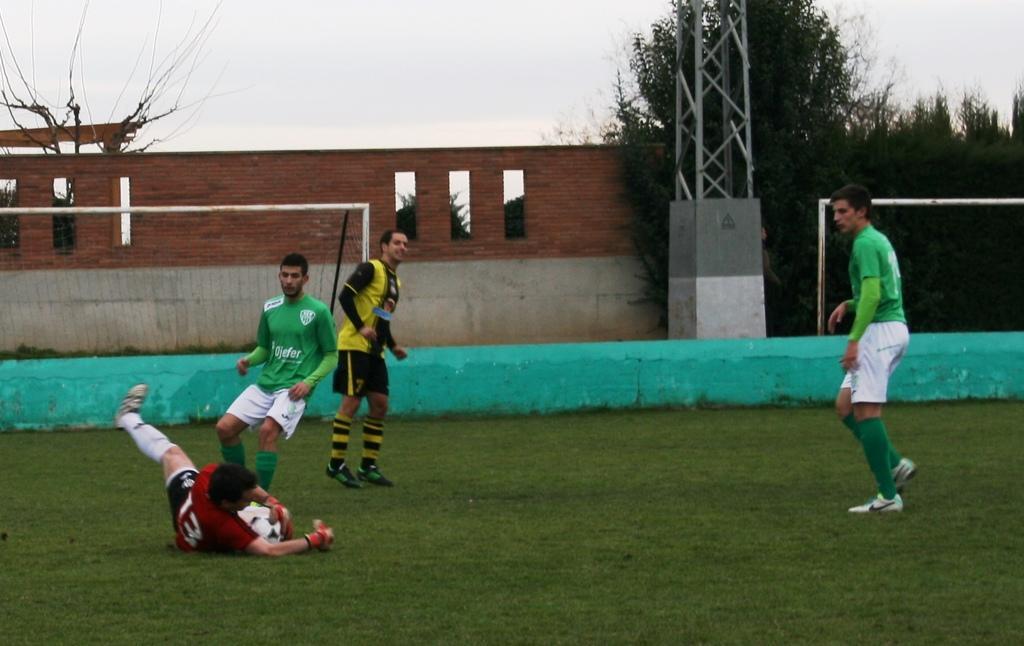How would you summarize this image in a sentence or two? On the left there is a man who is wearing green t-shirt, short and shoe. Beside him we can see a man who is wearing the red t-shirt, gloves, short and shoe. He is lying on the ground and holding football. Beside this man who is wearing a yellow t-shirt we can see a football net. On the right there is another man who is standing on the ground. In the background we can see the brick wall, electric pole and trees. In the top we can see sky and clouds. 